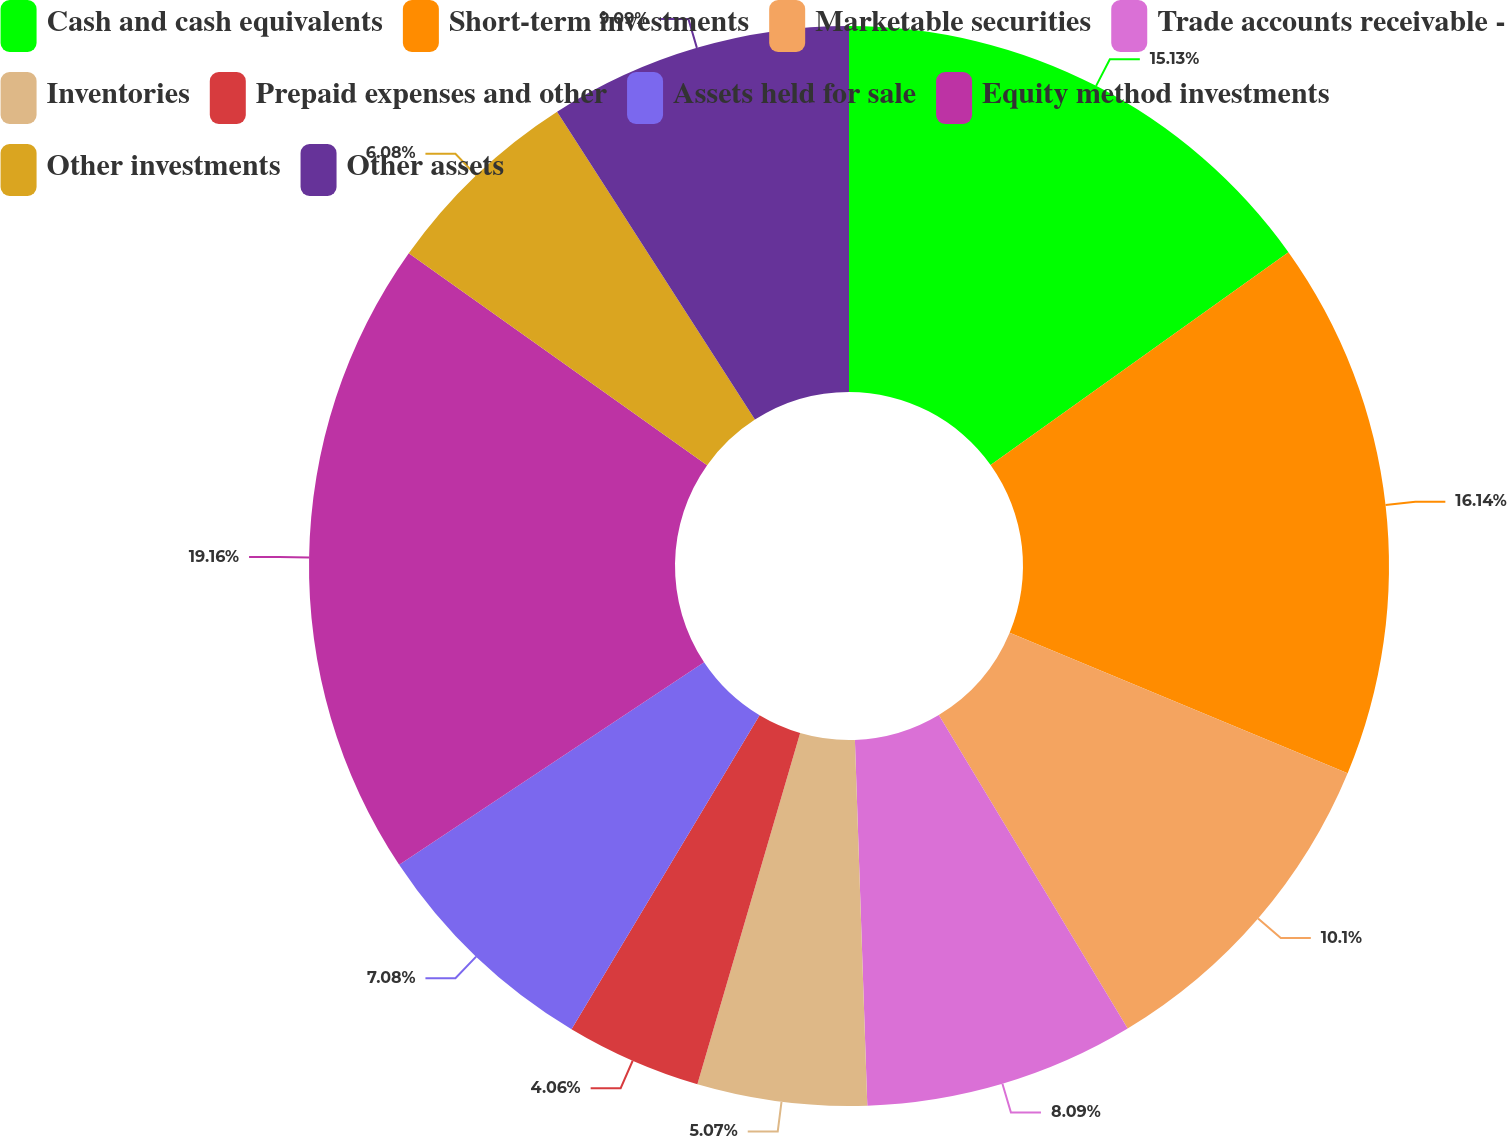Convert chart to OTSL. <chart><loc_0><loc_0><loc_500><loc_500><pie_chart><fcel>Cash and cash equivalents<fcel>Short-term investments<fcel>Marketable securities<fcel>Trade accounts receivable -<fcel>Inventories<fcel>Prepaid expenses and other<fcel>Assets held for sale<fcel>Equity method investments<fcel>Other investments<fcel>Other assets<nl><fcel>15.13%<fcel>16.14%<fcel>10.1%<fcel>8.09%<fcel>5.07%<fcel>4.06%<fcel>7.08%<fcel>19.16%<fcel>6.08%<fcel>9.09%<nl></chart> 